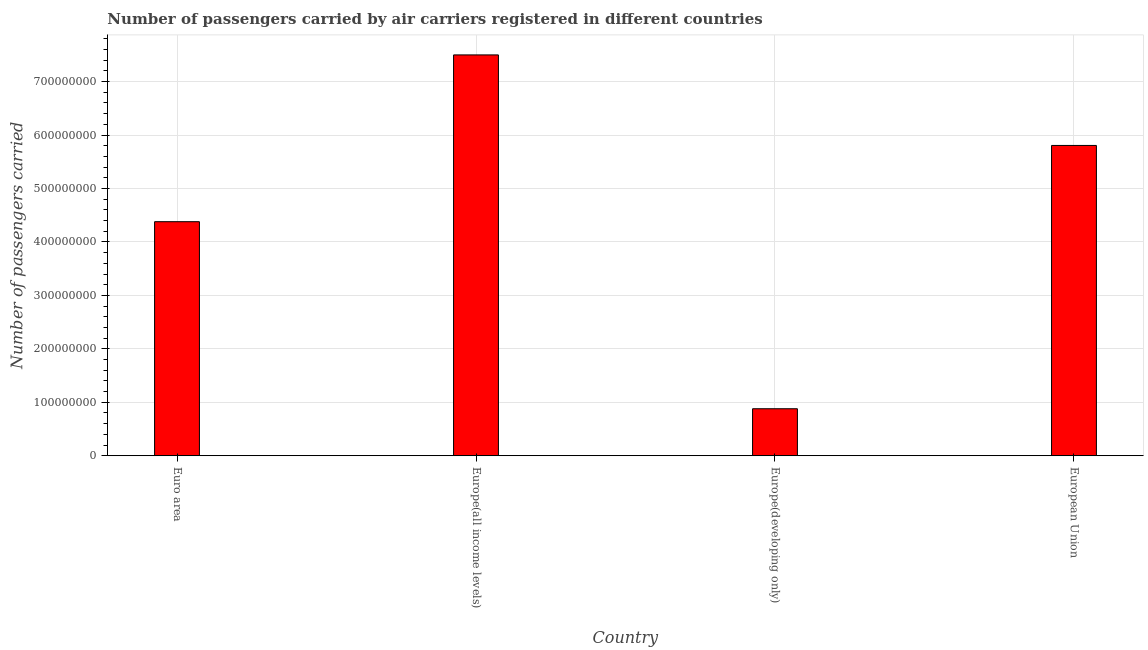What is the title of the graph?
Provide a short and direct response. Number of passengers carried by air carriers registered in different countries. What is the label or title of the Y-axis?
Your answer should be compact. Number of passengers carried. What is the number of passengers carried in Euro area?
Your answer should be very brief. 4.38e+08. Across all countries, what is the maximum number of passengers carried?
Offer a terse response. 7.50e+08. Across all countries, what is the minimum number of passengers carried?
Provide a succinct answer. 8.79e+07. In which country was the number of passengers carried maximum?
Provide a short and direct response. Europe(all income levels). In which country was the number of passengers carried minimum?
Your response must be concise. Europe(developing only). What is the sum of the number of passengers carried?
Keep it short and to the point. 1.86e+09. What is the difference between the number of passengers carried in Europe(all income levels) and European Union?
Ensure brevity in your answer.  1.69e+08. What is the average number of passengers carried per country?
Your answer should be very brief. 4.64e+08. What is the median number of passengers carried?
Provide a succinct answer. 5.09e+08. In how many countries, is the number of passengers carried greater than 380000000 ?
Provide a short and direct response. 3. What is the ratio of the number of passengers carried in Euro area to that in European Union?
Provide a short and direct response. 0.75. What is the difference between the highest and the second highest number of passengers carried?
Your response must be concise. 1.69e+08. Is the sum of the number of passengers carried in Euro area and Europe(all income levels) greater than the maximum number of passengers carried across all countries?
Your answer should be very brief. Yes. What is the difference between the highest and the lowest number of passengers carried?
Provide a short and direct response. 6.62e+08. In how many countries, is the number of passengers carried greater than the average number of passengers carried taken over all countries?
Give a very brief answer. 2. How many countries are there in the graph?
Offer a very short reply. 4. What is the Number of passengers carried of Euro area?
Keep it short and to the point. 4.38e+08. What is the Number of passengers carried in Europe(all income levels)?
Your answer should be compact. 7.50e+08. What is the Number of passengers carried of Europe(developing only)?
Offer a very short reply. 8.79e+07. What is the Number of passengers carried of European Union?
Ensure brevity in your answer.  5.81e+08. What is the difference between the Number of passengers carried in Euro area and Europe(all income levels)?
Keep it short and to the point. -3.12e+08. What is the difference between the Number of passengers carried in Euro area and Europe(developing only)?
Your answer should be very brief. 3.50e+08. What is the difference between the Number of passengers carried in Euro area and European Union?
Provide a short and direct response. -1.43e+08. What is the difference between the Number of passengers carried in Europe(all income levels) and Europe(developing only)?
Keep it short and to the point. 6.62e+08. What is the difference between the Number of passengers carried in Europe(all income levels) and European Union?
Provide a succinct answer. 1.69e+08. What is the difference between the Number of passengers carried in Europe(developing only) and European Union?
Keep it short and to the point. -4.93e+08. What is the ratio of the Number of passengers carried in Euro area to that in Europe(all income levels)?
Offer a very short reply. 0.58. What is the ratio of the Number of passengers carried in Euro area to that in Europe(developing only)?
Your answer should be very brief. 4.98. What is the ratio of the Number of passengers carried in Euro area to that in European Union?
Ensure brevity in your answer.  0.75. What is the ratio of the Number of passengers carried in Europe(all income levels) to that in Europe(developing only)?
Provide a succinct answer. 8.53. What is the ratio of the Number of passengers carried in Europe(all income levels) to that in European Union?
Offer a very short reply. 1.29. What is the ratio of the Number of passengers carried in Europe(developing only) to that in European Union?
Ensure brevity in your answer.  0.15. 